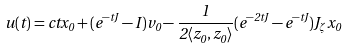<formula> <loc_0><loc_0><loc_500><loc_500>u ( t ) = c t x _ { 0 } + ( e ^ { - t J } - I ) v _ { 0 } - \frac { 1 } { 2 \langle z _ { 0 } , z _ { 0 } \rangle } ( e ^ { - 2 t J } - e ^ { - t J } ) J _ { \zeta } x _ { 0 }</formula> 